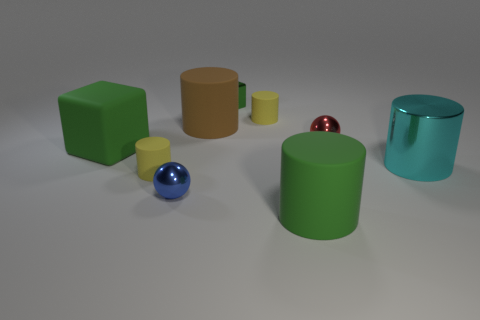Is the material of the yellow cylinder that is on the left side of the small metallic block the same as the cyan object?
Offer a terse response. No. How many other objects are there of the same color as the big cube?
Give a very brief answer. 2. How many other objects are the same shape as the blue object?
Make the answer very short. 1. Does the thing right of the tiny red ball have the same shape as the yellow rubber object left of the green metal block?
Make the answer very short. Yes. Are there an equal number of blue things that are to the left of the big green cube and blocks that are on the right side of the brown cylinder?
Ensure brevity in your answer.  No. There is a green thing in front of the big green object that is behind the green rubber thing that is in front of the big metal thing; what is its shape?
Your answer should be very brief. Cylinder. Are the green cylinder that is in front of the big cyan cylinder and the tiny sphere on the left side of the brown object made of the same material?
Provide a short and direct response. No. What is the shape of the big green matte thing to the right of the shiny cube?
Offer a terse response. Cylinder. Is the number of cyan shiny cylinders less than the number of big things?
Ensure brevity in your answer.  Yes. There is a tiny cylinder that is right of the shiny ball that is to the left of the small red metallic ball; are there any big green objects left of it?
Your answer should be compact. Yes. 